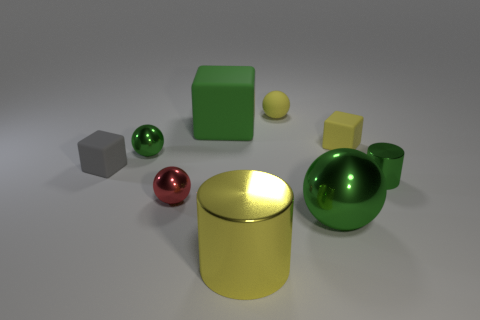Is the color of the rubber sphere the same as the large cylinder?
Offer a very short reply. Yes. Are there more small metal objects than things?
Your answer should be compact. No. Is there anything else that has the same size as the red thing?
Give a very brief answer. Yes. Does the green rubber thing to the right of the small red shiny object have the same shape as the big green metallic thing?
Make the answer very short. No. Are there more large cylinders behind the tiny red thing than large green cubes?
Offer a terse response. No. What is the color of the shiny cylinder that is on the right side of the rubber object that is on the right side of the large green ball?
Your answer should be very brief. Green. How many tiny metal spheres are there?
Make the answer very short. 2. What number of green objects are both in front of the big green rubber thing and left of the tiny green metal cylinder?
Your response must be concise. 2. Are there any other things that have the same shape as the yellow metallic object?
Your answer should be compact. Yes. There is a large matte block; does it have the same color as the tiny matte thing that is left of the big yellow metallic cylinder?
Offer a very short reply. No. 